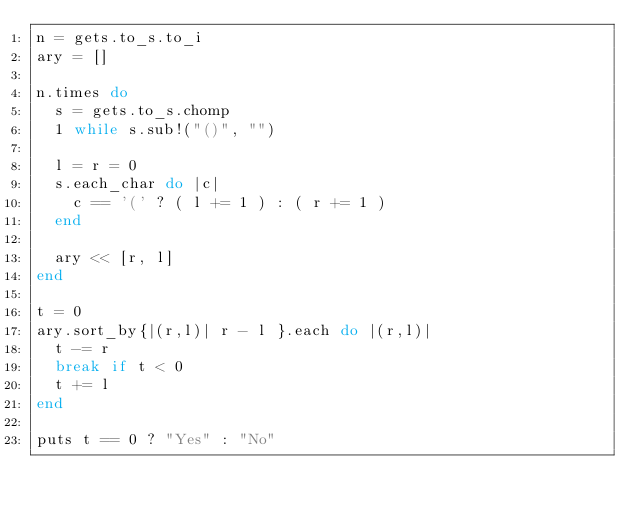Convert code to text. <code><loc_0><loc_0><loc_500><loc_500><_Ruby_>n = gets.to_s.to_i
ary = []

n.times do
  s = gets.to_s.chomp
  1 while s.sub!("()", "")

  l = r = 0
  s.each_char do |c|
    c == '(' ? ( l += 1 ) : ( r += 1 )
  end

  ary << [r, l]
end

t = 0
ary.sort_by{|(r,l)| r - l }.each do |(r,l)|
  t -= r
  break if t < 0
  t += l
end

puts t == 0 ? "Yes" : "No"</code> 